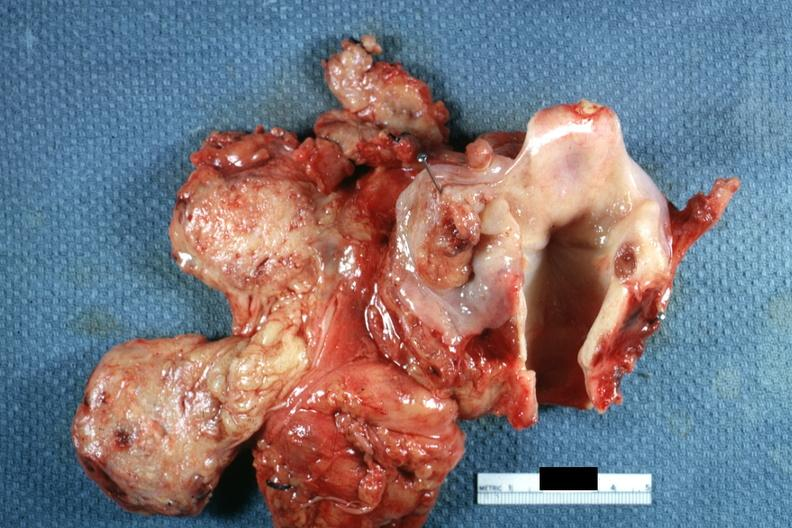what does this image show?
Answer the question using a single word or phrase. Well shown ulcerative lesion in right pyriform sinus 